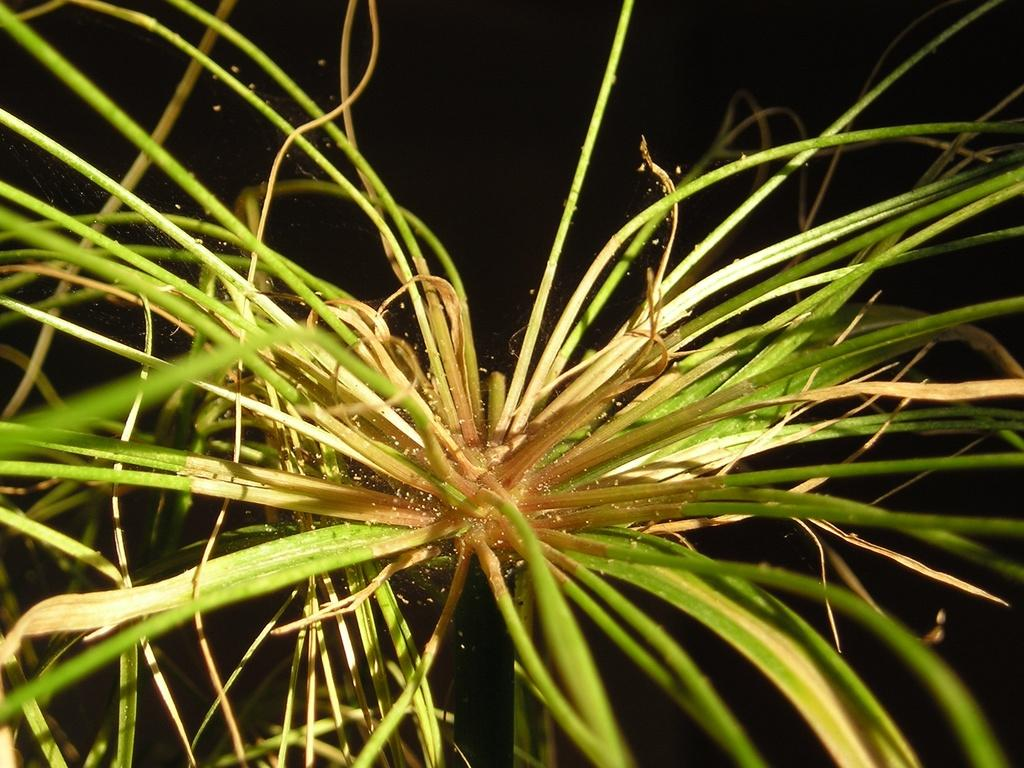What is present in the image? There is a plant in the image. What can be observed about the background of the image? The background of the image is dark. What songs can be heard playing in the background of the image? There is no audio or sound present in the image, so it is not possible to determine what songs might be heard. 